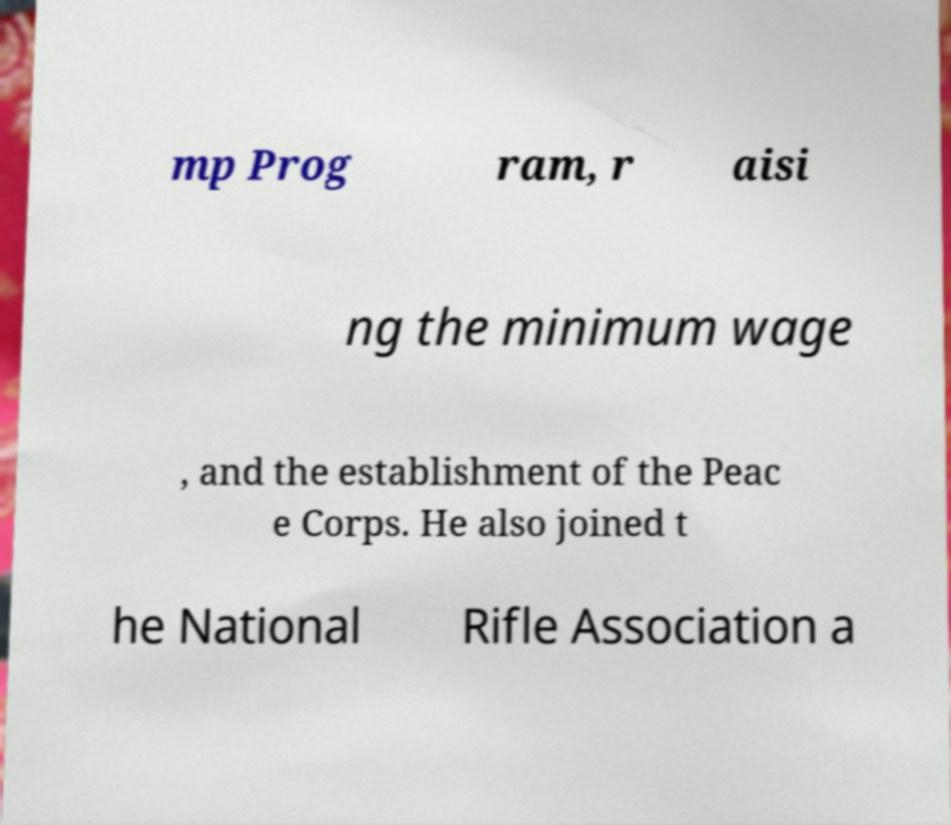Could you assist in decoding the text presented in this image and type it out clearly? mp Prog ram, r aisi ng the minimum wage , and the establishment of the Peac e Corps. He also joined t he National Rifle Association a 